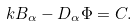Convert formula to latex. <formula><loc_0><loc_0><loc_500><loc_500>k B _ { \alpha } - D _ { \alpha } \Phi = C .</formula> 